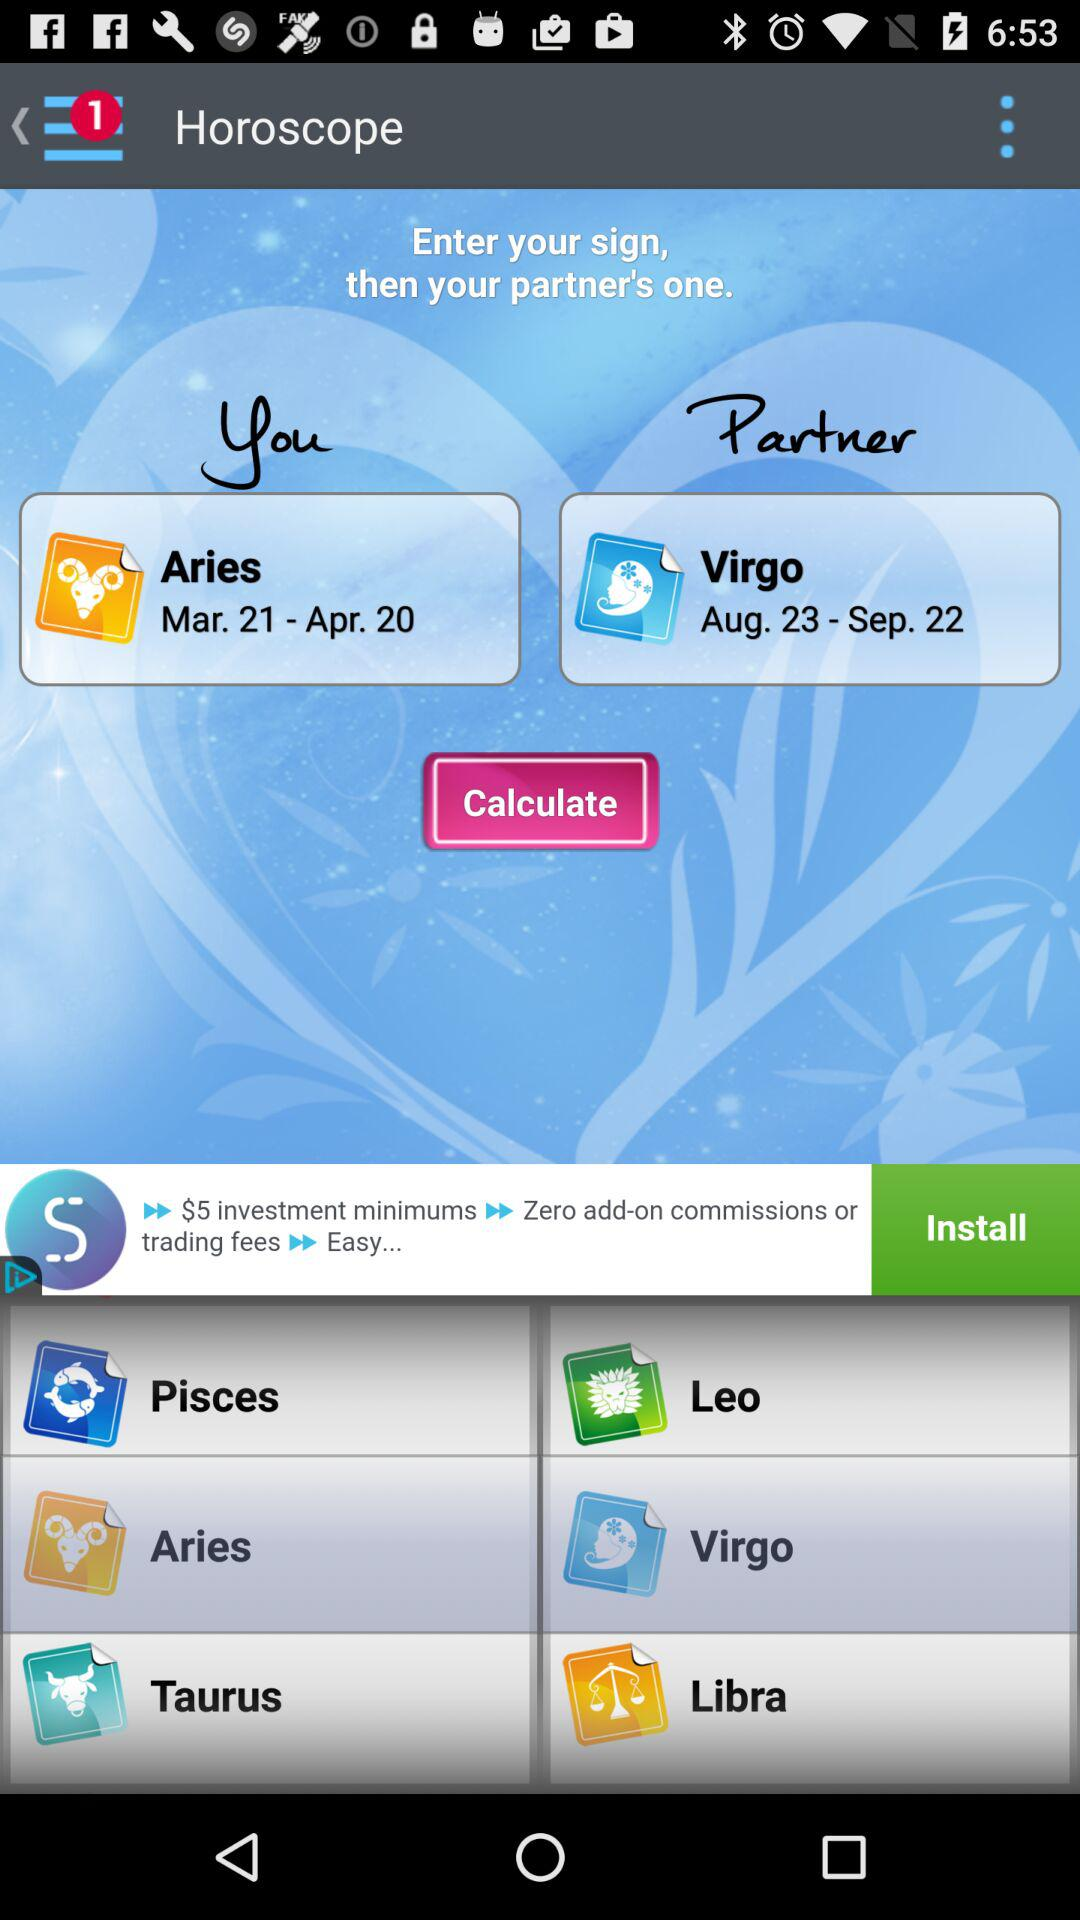What is my zodiac sign? Your zodiac sign is Aries. 